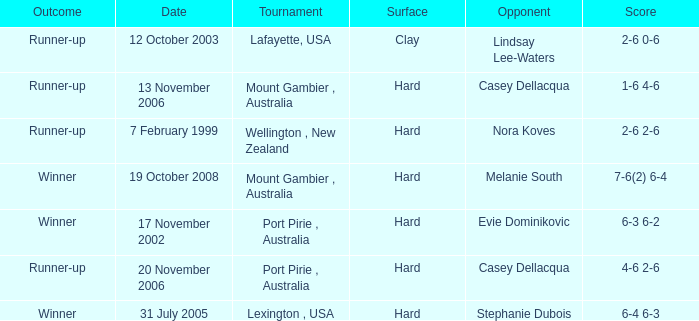When is an Opponent of evie dominikovic? 17 November 2002. 